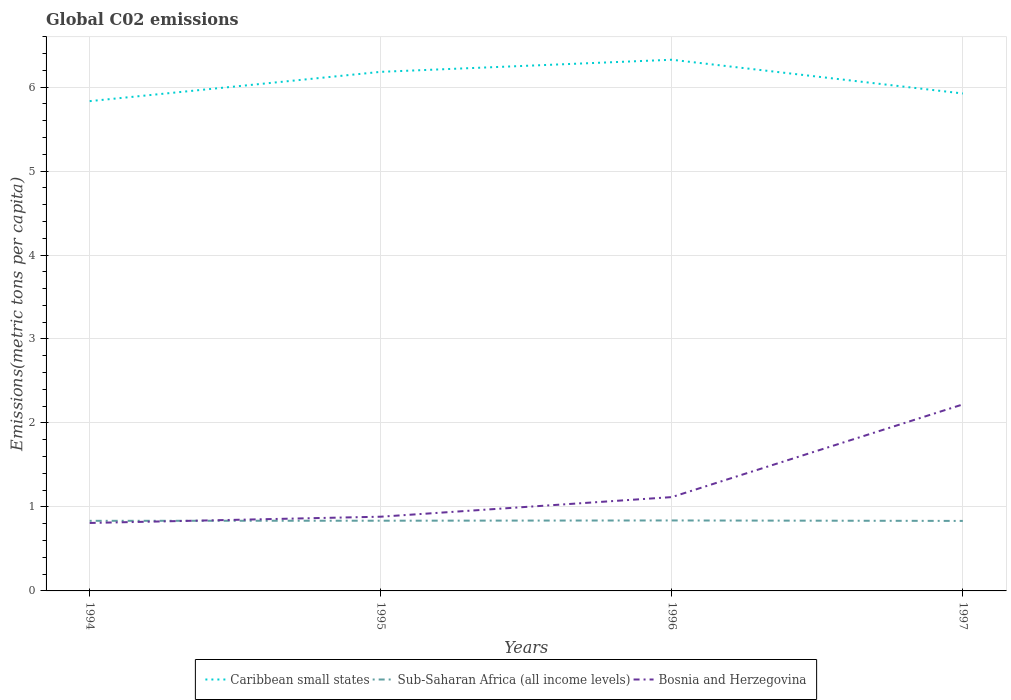Does the line corresponding to Caribbean small states intersect with the line corresponding to Sub-Saharan Africa (all income levels)?
Give a very brief answer. No. Is the number of lines equal to the number of legend labels?
Provide a short and direct response. Yes. Across all years, what is the maximum amount of CO2 emitted in in Caribbean small states?
Provide a succinct answer. 5.83. In which year was the amount of CO2 emitted in in Sub-Saharan Africa (all income levels) maximum?
Keep it short and to the point. 1997. What is the total amount of CO2 emitted in in Bosnia and Herzegovina in the graph?
Your answer should be compact. -0.31. What is the difference between the highest and the second highest amount of CO2 emitted in in Bosnia and Herzegovina?
Offer a terse response. 1.41. What is the difference between the highest and the lowest amount of CO2 emitted in in Sub-Saharan Africa (all income levels)?
Give a very brief answer. 2. How many lines are there?
Keep it short and to the point. 3. How many years are there in the graph?
Make the answer very short. 4. What is the difference between two consecutive major ticks on the Y-axis?
Provide a succinct answer. 1. Are the values on the major ticks of Y-axis written in scientific E-notation?
Your answer should be compact. No. Does the graph contain any zero values?
Your answer should be compact. No. What is the title of the graph?
Make the answer very short. Global C02 emissions. Does "Trinidad and Tobago" appear as one of the legend labels in the graph?
Ensure brevity in your answer.  No. What is the label or title of the X-axis?
Your response must be concise. Years. What is the label or title of the Y-axis?
Provide a succinct answer. Emissions(metric tons per capita). What is the Emissions(metric tons per capita) of Caribbean small states in 1994?
Make the answer very short. 5.83. What is the Emissions(metric tons per capita) in Sub-Saharan Africa (all income levels) in 1994?
Offer a very short reply. 0.83. What is the Emissions(metric tons per capita) of Bosnia and Herzegovina in 1994?
Provide a short and direct response. 0.81. What is the Emissions(metric tons per capita) in Caribbean small states in 1995?
Provide a succinct answer. 6.18. What is the Emissions(metric tons per capita) in Sub-Saharan Africa (all income levels) in 1995?
Your response must be concise. 0.84. What is the Emissions(metric tons per capita) of Bosnia and Herzegovina in 1995?
Your answer should be compact. 0.88. What is the Emissions(metric tons per capita) of Caribbean small states in 1996?
Provide a succinct answer. 6.33. What is the Emissions(metric tons per capita) in Sub-Saharan Africa (all income levels) in 1996?
Your response must be concise. 0.84. What is the Emissions(metric tons per capita) of Bosnia and Herzegovina in 1996?
Offer a very short reply. 1.12. What is the Emissions(metric tons per capita) in Caribbean small states in 1997?
Ensure brevity in your answer.  5.92. What is the Emissions(metric tons per capita) in Sub-Saharan Africa (all income levels) in 1997?
Offer a terse response. 0.83. What is the Emissions(metric tons per capita) in Bosnia and Herzegovina in 1997?
Make the answer very short. 2.22. Across all years, what is the maximum Emissions(metric tons per capita) in Caribbean small states?
Ensure brevity in your answer.  6.33. Across all years, what is the maximum Emissions(metric tons per capita) of Sub-Saharan Africa (all income levels)?
Ensure brevity in your answer.  0.84. Across all years, what is the maximum Emissions(metric tons per capita) in Bosnia and Herzegovina?
Offer a very short reply. 2.22. Across all years, what is the minimum Emissions(metric tons per capita) in Caribbean small states?
Provide a short and direct response. 5.83. Across all years, what is the minimum Emissions(metric tons per capita) of Sub-Saharan Africa (all income levels)?
Keep it short and to the point. 0.83. Across all years, what is the minimum Emissions(metric tons per capita) in Bosnia and Herzegovina?
Your answer should be very brief. 0.81. What is the total Emissions(metric tons per capita) in Caribbean small states in the graph?
Make the answer very short. 24.26. What is the total Emissions(metric tons per capita) of Sub-Saharan Africa (all income levels) in the graph?
Offer a terse response. 3.34. What is the total Emissions(metric tons per capita) of Bosnia and Herzegovina in the graph?
Make the answer very short. 5.03. What is the difference between the Emissions(metric tons per capita) of Caribbean small states in 1994 and that in 1995?
Your response must be concise. -0.35. What is the difference between the Emissions(metric tons per capita) in Sub-Saharan Africa (all income levels) in 1994 and that in 1995?
Your answer should be compact. -0. What is the difference between the Emissions(metric tons per capita) in Bosnia and Herzegovina in 1994 and that in 1995?
Give a very brief answer. -0.07. What is the difference between the Emissions(metric tons per capita) in Caribbean small states in 1994 and that in 1996?
Offer a terse response. -0.49. What is the difference between the Emissions(metric tons per capita) in Sub-Saharan Africa (all income levels) in 1994 and that in 1996?
Offer a terse response. -0. What is the difference between the Emissions(metric tons per capita) of Bosnia and Herzegovina in 1994 and that in 1996?
Your answer should be very brief. -0.31. What is the difference between the Emissions(metric tons per capita) in Caribbean small states in 1994 and that in 1997?
Keep it short and to the point. -0.09. What is the difference between the Emissions(metric tons per capita) in Sub-Saharan Africa (all income levels) in 1994 and that in 1997?
Your answer should be very brief. 0. What is the difference between the Emissions(metric tons per capita) in Bosnia and Herzegovina in 1994 and that in 1997?
Provide a succinct answer. -1.41. What is the difference between the Emissions(metric tons per capita) of Caribbean small states in 1995 and that in 1996?
Provide a short and direct response. -0.14. What is the difference between the Emissions(metric tons per capita) of Sub-Saharan Africa (all income levels) in 1995 and that in 1996?
Ensure brevity in your answer.  -0. What is the difference between the Emissions(metric tons per capita) in Bosnia and Herzegovina in 1995 and that in 1996?
Provide a succinct answer. -0.23. What is the difference between the Emissions(metric tons per capita) of Caribbean small states in 1995 and that in 1997?
Provide a short and direct response. 0.26. What is the difference between the Emissions(metric tons per capita) of Sub-Saharan Africa (all income levels) in 1995 and that in 1997?
Keep it short and to the point. 0. What is the difference between the Emissions(metric tons per capita) in Bosnia and Herzegovina in 1995 and that in 1997?
Ensure brevity in your answer.  -1.34. What is the difference between the Emissions(metric tons per capita) of Caribbean small states in 1996 and that in 1997?
Provide a short and direct response. 0.4. What is the difference between the Emissions(metric tons per capita) of Sub-Saharan Africa (all income levels) in 1996 and that in 1997?
Offer a very short reply. 0.01. What is the difference between the Emissions(metric tons per capita) of Bosnia and Herzegovina in 1996 and that in 1997?
Offer a terse response. -1.1. What is the difference between the Emissions(metric tons per capita) of Caribbean small states in 1994 and the Emissions(metric tons per capita) of Sub-Saharan Africa (all income levels) in 1995?
Your response must be concise. 5. What is the difference between the Emissions(metric tons per capita) in Caribbean small states in 1994 and the Emissions(metric tons per capita) in Bosnia and Herzegovina in 1995?
Your answer should be compact. 4.95. What is the difference between the Emissions(metric tons per capita) of Sub-Saharan Africa (all income levels) in 1994 and the Emissions(metric tons per capita) of Bosnia and Herzegovina in 1995?
Your response must be concise. -0.05. What is the difference between the Emissions(metric tons per capita) in Caribbean small states in 1994 and the Emissions(metric tons per capita) in Sub-Saharan Africa (all income levels) in 1996?
Provide a short and direct response. 4.99. What is the difference between the Emissions(metric tons per capita) of Caribbean small states in 1994 and the Emissions(metric tons per capita) of Bosnia and Herzegovina in 1996?
Keep it short and to the point. 4.72. What is the difference between the Emissions(metric tons per capita) in Sub-Saharan Africa (all income levels) in 1994 and the Emissions(metric tons per capita) in Bosnia and Herzegovina in 1996?
Your response must be concise. -0.28. What is the difference between the Emissions(metric tons per capita) in Caribbean small states in 1994 and the Emissions(metric tons per capita) in Sub-Saharan Africa (all income levels) in 1997?
Give a very brief answer. 5. What is the difference between the Emissions(metric tons per capita) in Caribbean small states in 1994 and the Emissions(metric tons per capita) in Bosnia and Herzegovina in 1997?
Your answer should be compact. 3.61. What is the difference between the Emissions(metric tons per capita) of Sub-Saharan Africa (all income levels) in 1994 and the Emissions(metric tons per capita) of Bosnia and Herzegovina in 1997?
Make the answer very short. -1.39. What is the difference between the Emissions(metric tons per capita) of Caribbean small states in 1995 and the Emissions(metric tons per capita) of Sub-Saharan Africa (all income levels) in 1996?
Make the answer very short. 5.34. What is the difference between the Emissions(metric tons per capita) in Caribbean small states in 1995 and the Emissions(metric tons per capita) in Bosnia and Herzegovina in 1996?
Keep it short and to the point. 5.06. What is the difference between the Emissions(metric tons per capita) of Sub-Saharan Africa (all income levels) in 1995 and the Emissions(metric tons per capita) of Bosnia and Herzegovina in 1996?
Make the answer very short. -0.28. What is the difference between the Emissions(metric tons per capita) in Caribbean small states in 1995 and the Emissions(metric tons per capita) in Sub-Saharan Africa (all income levels) in 1997?
Provide a succinct answer. 5.35. What is the difference between the Emissions(metric tons per capita) of Caribbean small states in 1995 and the Emissions(metric tons per capita) of Bosnia and Herzegovina in 1997?
Provide a succinct answer. 3.96. What is the difference between the Emissions(metric tons per capita) in Sub-Saharan Africa (all income levels) in 1995 and the Emissions(metric tons per capita) in Bosnia and Herzegovina in 1997?
Offer a terse response. -1.38. What is the difference between the Emissions(metric tons per capita) of Caribbean small states in 1996 and the Emissions(metric tons per capita) of Sub-Saharan Africa (all income levels) in 1997?
Offer a very short reply. 5.49. What is the difference between the Emissions(metric tons per capita) of Caribbean small states in 1996 and the Emissions(metric tons per capita) of Bosnia and Herzegovina in 1997?
Make the answer very short. 4.1. What is the difference between the Emissions(metric tons per capita) in Sub-Saharan Africa (all income levels) in 1996 and the Emissions(metric tons per capita) in Bosnia and Herzegovina in 1997?
Offer a very short reply. -1.38. What is the average Emissions(metric tons per capita) of Caribbean small states per year?
Ensure brevity in your answer.  6.07. What is the average Emissions(metric tons per capita) of Sub-Saharan Africa (all income levels) per year?
Make the answer very short. 0.84. What is the average Emissions(metric tons per capita) in Bosnia and Herzegovina per year?
Make the answer very short. 1.26. In the year 1994, what is the difference between the Emissions(metric tons per capita) of Caribbean small states and Emissions(metric tons per capita) of Sub-Saharan Africa (all income levels)?
Offer a very short reply. 5. In the year 1994, what is the difference between the Emissions(metric tons per capita) of Caribbean small states and Emissions(metric tons per capita) of Bosnia and Herzegovina?
Provide a succinct answer. 5.02. In the year 1994, what is the difference between the Emissions(metric tons per capita) in Sub-Saharan Africa (all income levels) and Emissions(metric tons per capita) in Bosnia and Herzegovina?
Make the answer very short. 0.03. In the year 1995, what is the difference between the Emissions(metric tons per capita) in Caribbean small states and Emissions(metric tons per capita) in Sub-Saharan Africa (all income levels)?
Your answer should be very brief. 5.35. In the year 1995, what is the difference between the Emissions(metric tons per capita) in Caribbean small states and Emissions(metric tons per capita) in Bosnia and Herzegovina?
Provide a short and direct response. 5.3. In the year 1995, what is the difference between the Emissions(metric tons per capita) in Sub-Saharan Africa (all income levels) and Emissions(metric tons per capita) in Bosnia and Herzegovina?
Provide a succinct answer. -0.05. In the year 1996, what is the difference between the Emissions(metric tons per capita) in Caribbean small states and Emissions(metric tons per capita) in Sub-Saharan Africa (all income levels)?
Your answer should be very brief. 5.49. In the year 1996, what is the difference between the Emissions(metric tons per capita) of Caribbean small states and Emissions(metric tons per capita) of Bosnia and Herzegovina?
Make the answer very short. 5.21. In the year 1996, what is the difference between the Emissions(metric tons per capita) in Sub-Saharan Africa (all income levels) and Emissions(metric tons per capita) in Bosnia and Herzegovina?
Provide a succinct answer. -0.28. In the year 1997, what is the difference between the Emissions(metric tons per capita) of Caribbean small states and Emissions(metric tons per capita) of Sub-Saharan Africa (all income levels)?
Provide a succinct answer. 5.09. In the year 1997, what is the difference between the Emissions(metric tons per capita) in Caribbean small states and Emissions(metric tons per capita) in Bosnia and Herzegovina?
Give a very brief answer. 3.7. In the year 1997, what is the difference between the Emissions(metric tons per capita) in Sub-Saharan Africa (all income levels) and Emissions(metric tons per capita) in Bosnia and Herzegovina?
Give a very brief answer. -1.39. What is the ratio of the Emissions(metric tons per capita) in Caribbean small states in 1994 to that in 1995?
Keep it short and to the point. 0.94. What is the ratio of the Emissions(metric tons per capita) in Sub-Saharan Africa (all income levels) in 1994 to that in 1995?
Ensure brevity in your answer.  1. What is the ratio of the Emissions(metric tons per capita) in Bosnia and Herzegovina in 1994 to that in 1995?
Offer a terse response. 0.92. What is the ratio of the Emissions(metric tons per capita) of Caribbean small states in 1994 to that in 1996?
Your answer should be very brief. 0.92. What is the ratio of the Emissions(metric tons per capita) in Bosnia and Herzegovina in 1994 to that in 1996?
Offer a terse response. 0.72. What is the ratio of the Emissions(metric tons per capita) of Caribbean small states in 1994 to that in 1997?
Offer a very short reply. 0.98. What is the ratio of the Emissions(metric tons per capita) of Bosnia and Herzegovina in 1994 to that in 1997?
Provide a short and direct response. 0.36. What is the ratio of the Emissions(metric tons per capita) of Caribbean small states in 1995 to that in 1996?
Make the answer very short. 0.98. What is the ratio of the Emissions(metric tons per capita) in Bosnia and Herzegovina in 1995 to that in 1996?
Your response must be concise. 0.79. What is the ratio of the Emissions(metric tons per capita) in Caribbean small states in 1995 to that in 1997?
Keep it short and to the point. 1.04. What is the ratio of the Emissions(metric tons per capita) of Bosnia and Herzegovina in 1995 to that in 1997?
Offer a very short reply. 0.4. What is the ratio of the Emissions(metric tons per capita) of Caribbean small states in 1996 to that in 1997?
Provide a succinct answer. 1.07. What is the ratio of the Emissions(metric tons per capita) of Bosnia and Herzegovina in 1996 to that in 1997?
Your answer should be very brief. 0.5. What is the difference between the highest and the second highest Emissions(metric tons per capita) in Caribbean small states?
Keep it short and to the point. 0.14. What is the difference between the highest and the second highest Emissions(metric tons per capita) in Sub-Saharan Africa (all income levels)?
Make the answer very short. 0. What is the difference between the highest and the second highest Emissions(metric tons per capita) of Bosnia and Herzegovina?
Your answer should be compact. 1.1. What is the difference between the highest and the lowest Emissions(metric tons per capita) in Caribbean small states?
Provide a short and direct response. 0.49. What is the difference between the highest and the lowest Emissions(metric tons per capita) in Sub-Saharan Africa (all income levels)?
Your response must be concise. 0.01. What is the difference between the highest and the lowest Emissions(metric tons per capita) of Bosnia and Herzegovina?
Offer a terse response. 1.41. 